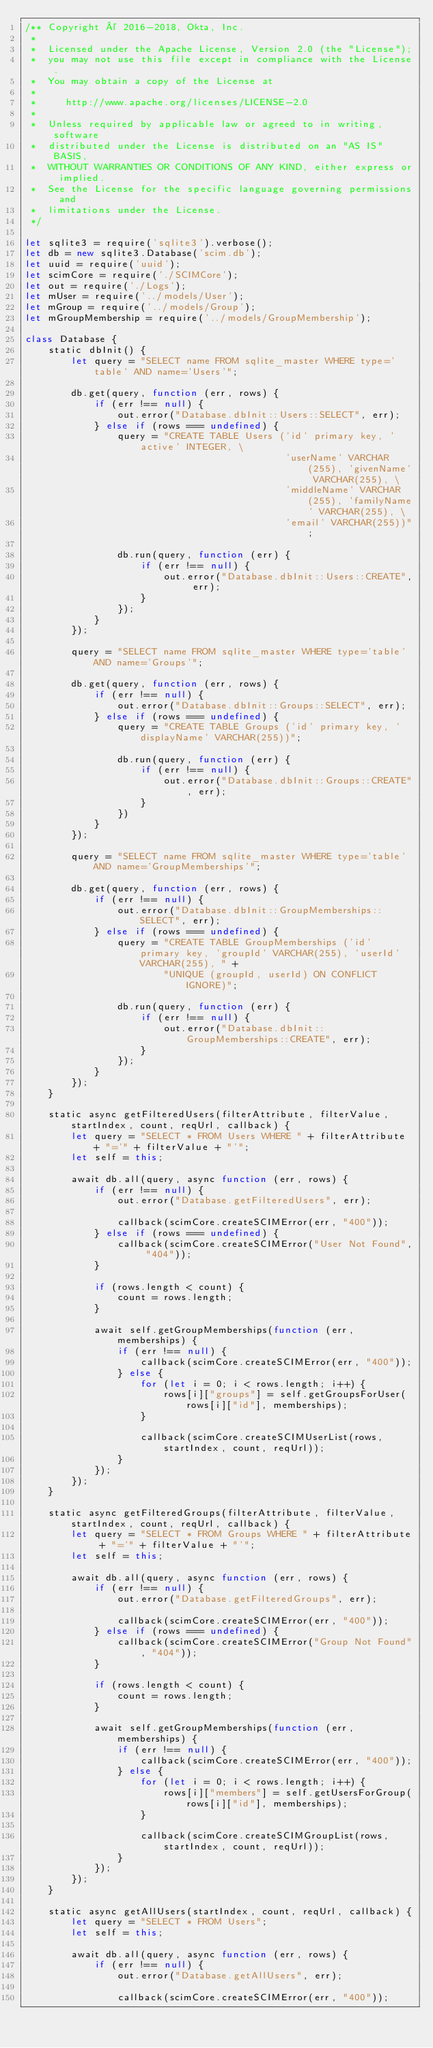<code> <loc_0><loc_0><loc_500><loc_500><_JavaScript_>/** Copyright © 2016-2018, Okta, Inc.
 *
 *  Licensed under the Apache License, Version 2.0 (the "License");
 *  you may not use this file except in compliance with the License.
 *  You may obtain a copy of the License at
 *
 *     http://www.apache.org/licenses/LICENSE-2.0
 *
 *  Unless required by applicable law or agreed to in writing, software
 *  distributed under the License is distributed on an "AS IS" BASIS,
 *  WITHOUT WARRANTIES OR CONDITIONS OF ANY KIND, either express or implied.
 *  See the License for the specific language governing permissions and
 *  limitations under the License.
 */

let sqlite3 = require('sqlite3').verbose();
let db = new sqlite3.Database('scim.db');
let uuid = require('uuid');
let scimCore = require('./SCIMCore');
let out = require('./Logs');
let mUser = require('../models/User');
let mGroup = require('../models/Group');
let mGroupMembership = require('../models/GroupMembership');

class Database {
    static dbInit() {
        let query = "SELECT name FROM sqlite_master WHERE type='table' AND name='Users'";

        db.get(query, function (err, rows) {
            if (err !== null) {
                out.error("Database.dbInit::Users::SELECT", err);
            } else if (rows === undefined) {
                query = "CREATE TABLE Users ('id' primary key, 'active' INTEGER, \
                                             'userName' VARCHAR(255), 'givenName' VARCHAR(255), \
                                             'middleName' VARCHAR(255), 'familyName' VARCHAR(255), \
                                             'email' VARCHAR(255))";

                db.run(query, function (err) {
                    if (err !== null) {
                        out.error("Database.dbInit::Users::CREATE", err);
                    }
                });
            }
        });

        query = "SELECT name FROM sqlite_master WHERE type='table' AND name='Groups'";

        db.get(query, function (err, rows) {
            if (err !== null) {
                out.error("Database.dbInit::Groups::SELECT", err);
            } else if (rows === undefined) {
                query = "CREATE TABLE Groups ('id' primary key, 'displayName' VARCHAR(255))";

                db.run(query, function (err) {
                    if (err !== null) {
                        out.error("Database.dbInit::Groups::CREATE", err);
                    }
                })
            }
        });

        query = "SELECT name FROM sqlite_master WHERE type='table' AND name='GroupMemberships'";

        db.get(query, function (err, rows) {
            if (err !== null) {
                out.error("Database.dbInit::GroupMemberships::SELECT", err);
            } else if (rows === undefined) {
                query = "CREATE TABLE GroupMemberships ('id' primary key, 'groupId' VARCHAR(255), 'userId' VARCHAR(255), " +
                        "UNIQUE (groupId, userId) ON CONFLICT IGNORE)";

                db.run(query, function (err) {
                    if (err !== null) {
                        out.error("Database.dbInit::GroupMemberships::CREATE", err);
                    }
                });
            }
        });
    }

    static async getFilteredUsers(filterAttribute, filterValue, startIndex, count, reqUrl, callback) {
        let query = "SELECT * FROM Users WHERE " + filterAttribute + "='" + filterValue + "'";
        let self = this;

        await db.all(query, async function (err, rows) {
            if (err !== null) {
                out.error("Database.getFilteredUsers", err);

                callback(scimCore.createSCIMError(err, "400"));
            } else if (rows === undefined) {
                callback(scimCore.createSCIMError("User Not Found", "404"));
            }

            if (rows.length < count) {
                count = rows.length;
            }

            await self.getGroupMemberships(function (err, memberships) {
                if (err !== null) {
                    callback(scimCore.createSCIMError(err, "400"));
                } else {
                    for (let i = 0; i < rows.length; i++) {
                        rows[i]["groups"] = self.getGroupsForUser(rows[i]["id"], memberships);
                    }

                    callback(scimCore.createSCIMUserList(rows, startIndex, count, reqUrl));
                }
            });
        });
    }

    static async getFilteredGroups(filterAttribute, filterValue, startIndex, count, reqUrl, callback) {
        let query = "SELECT * FROM Groups WHERE " + filterAttribute + "='" + filterValue + "'";
        let self = this;

        await db.all(query, async function (err, rows) {
            if (err !== null) {
                out.error("Database.getFilteredGroups", err);

                callback(scimCore.createSCIMError(err, "400"));
            } else if (rows === undefined) {
                callback(scimCore.createSCIMError("Group Not Found", "404"));
            }

            if (rows.length < count) {
                count = rows.length;
            }

            await self.getGroupMemberships(function (err, memberships) {
                if (err !== null) {
                    callback(scimCore.createSCIMError(err, "400"));
                } else {
                    for (let i = 0; i < rows.length; i++) {
                        rows[i]["members"] = self.getUsersForGroup(rows[i]["id"], memberships);
                    }

                    callback(scimCore.createSCIMGroupList(rows, startIndex, count, reqUrl));
                }
            });
        });
    }

    static async getAllUsers(startIndex, count, reqUrl, callback) {
        let query = "SELECT * FROM Users";
        let self = this;

        await db.all(query, async function (err, rows) {
            if (err !== null) {
                out.error("Database.getAllUsers", err);

                callback(scimCore.createSCIMError(err, "400"));</code> 